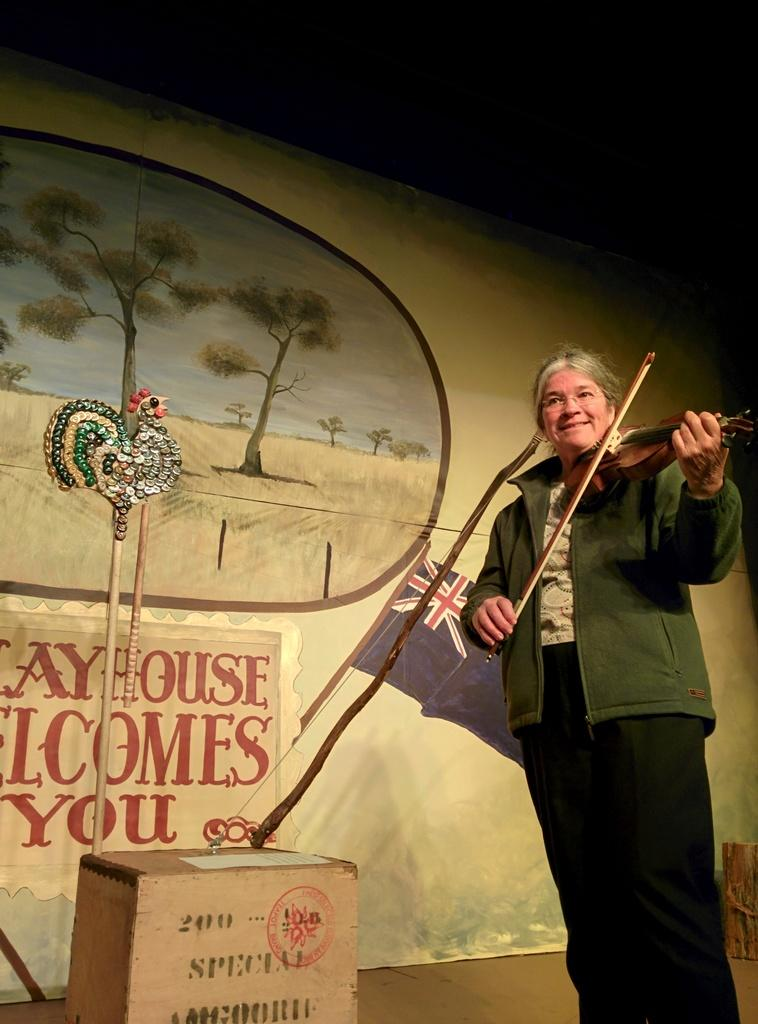What is the person in the image doing? There is a person playing a violin in the image. What object can be seen next to the person? There is a wooden box with a decorative item in the image. What can be seen on the wall in the background of the image? There is a wall with text and an image in the background of the image. Can you see the maid cleaning the throat of the rabbit in the image? There is no maid, throat, or rabbit present in the image. 